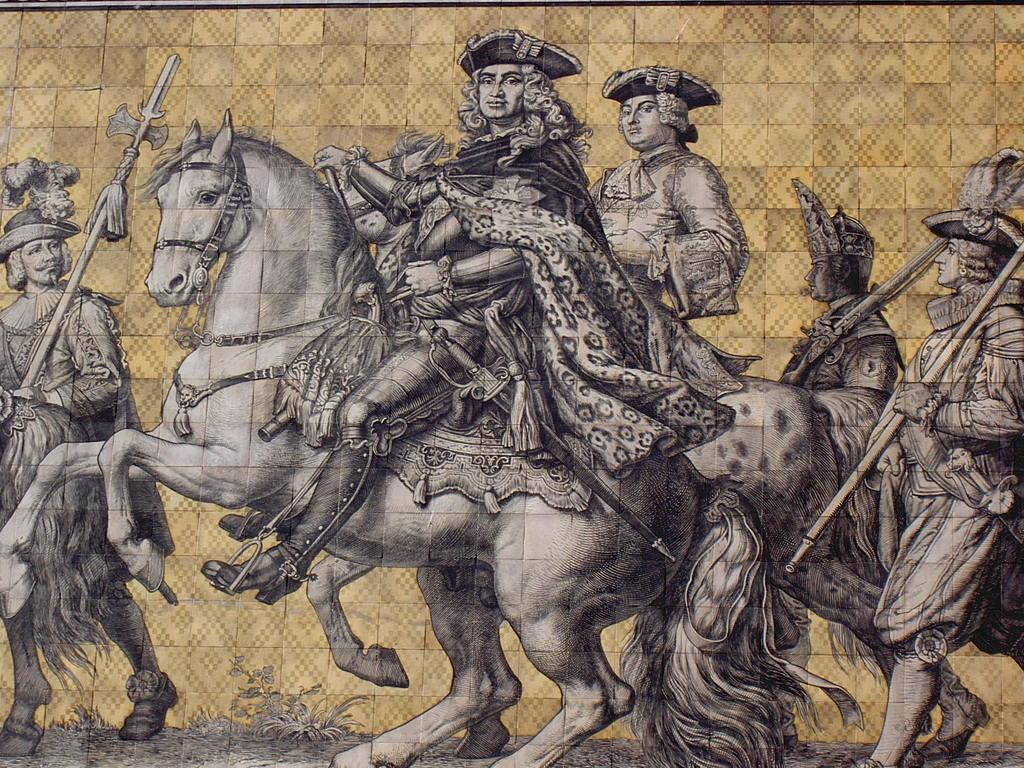Could you give a brief overview of what you see in this image? This image is an edited image in which there are persons riding a horse and there are persons walking. 